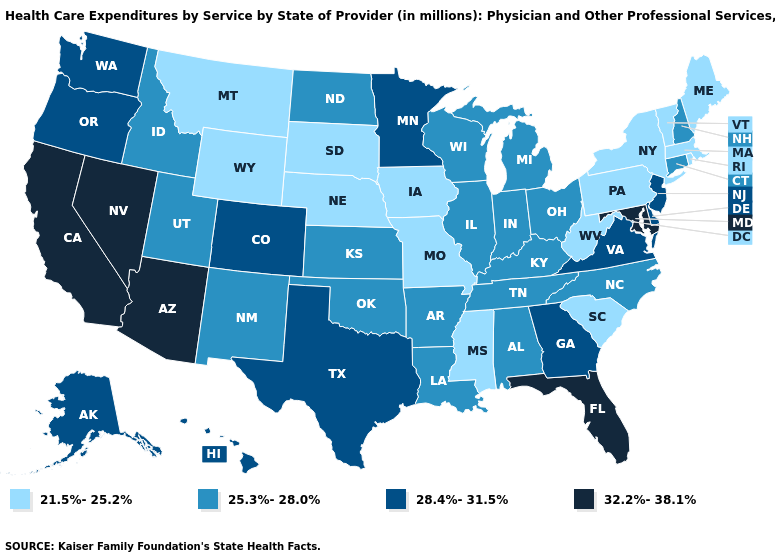What is the highest value in the Northeast ?
Answer briefly. 28.4%-31.5%. Is the legend a continuous bar?
Keep it brief. No. What is the value of Louisiana?
Short answer required. 25.3%-28.0%. Which states have the lowest value in the South?
Write a very short answer. Mississippi, South Carolina, West Virginia. Does the map have missing data?
Concise answer only. No. What is the highest value in the Northeast ?
Give a very brief answer. 28.4%-31.5%. How many symbols are there in the legend?
Be succinct. 4. How many symbols are there in the legend?
Quick response, please. 4. What is the value of Delaware?
Quick response, please. 28.4%-31.5%. Does Massachusetts have the highest value in the USA?
Be succinct. No. Does Iowa have the highest value in the MidWest?
Answer briefly. No. What is the value of Wyoming?
Short answer required. 21.5%-25.2%. Does Delaware have a higher value than Maryland?
Answer briefly. No. Name the states that have a value in the range 32.2%-38.1%?
Keep it brief. Arizona, California, Florida, Maryland, Nevada. What is the highest value in the Northeast ?
Concise answer only. 28.4%-31.5%. 